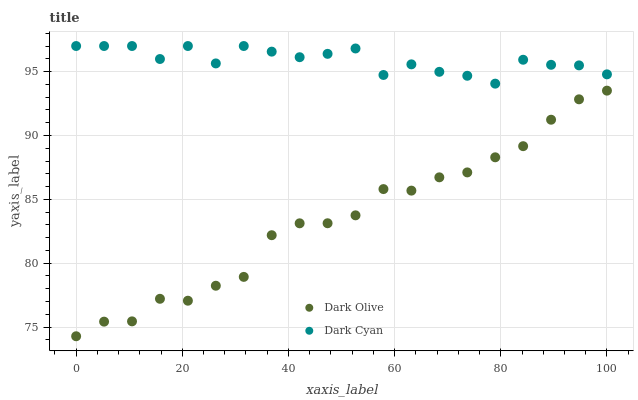Does Dark Olive have the minimum area under the curve?
Answer yes or no. Yes. Does Dark Cyan have the maximum area under the curve?
Answer yes or no. Yes. Does Dark Olive have the maximum area under the curve?
Answer yes or no. No. Is Dark Olive the smoothest?
Answer yes or no. Yes. Is Dark Cyan the roughest?
Answer yes or no. Yes. Is Dark Olive the roughest?
Answer yes or no. No. Does Dark Olive have the lowest value?
Answer yes or no. Yes. Does Dark Cyan have the highest value?
Answer yes or no. Yes. Does Dark Olive have the highest value?
Answer yes or no. No. Is Dark Olive less than Dark Cyan?
Answer yes or no. Yes. Is Dark Cyan greater than Dark Olive?
Answer yes or no. Yes. Does Dark Olive intersect Dark Cyan?
Answer yes or no. No. 